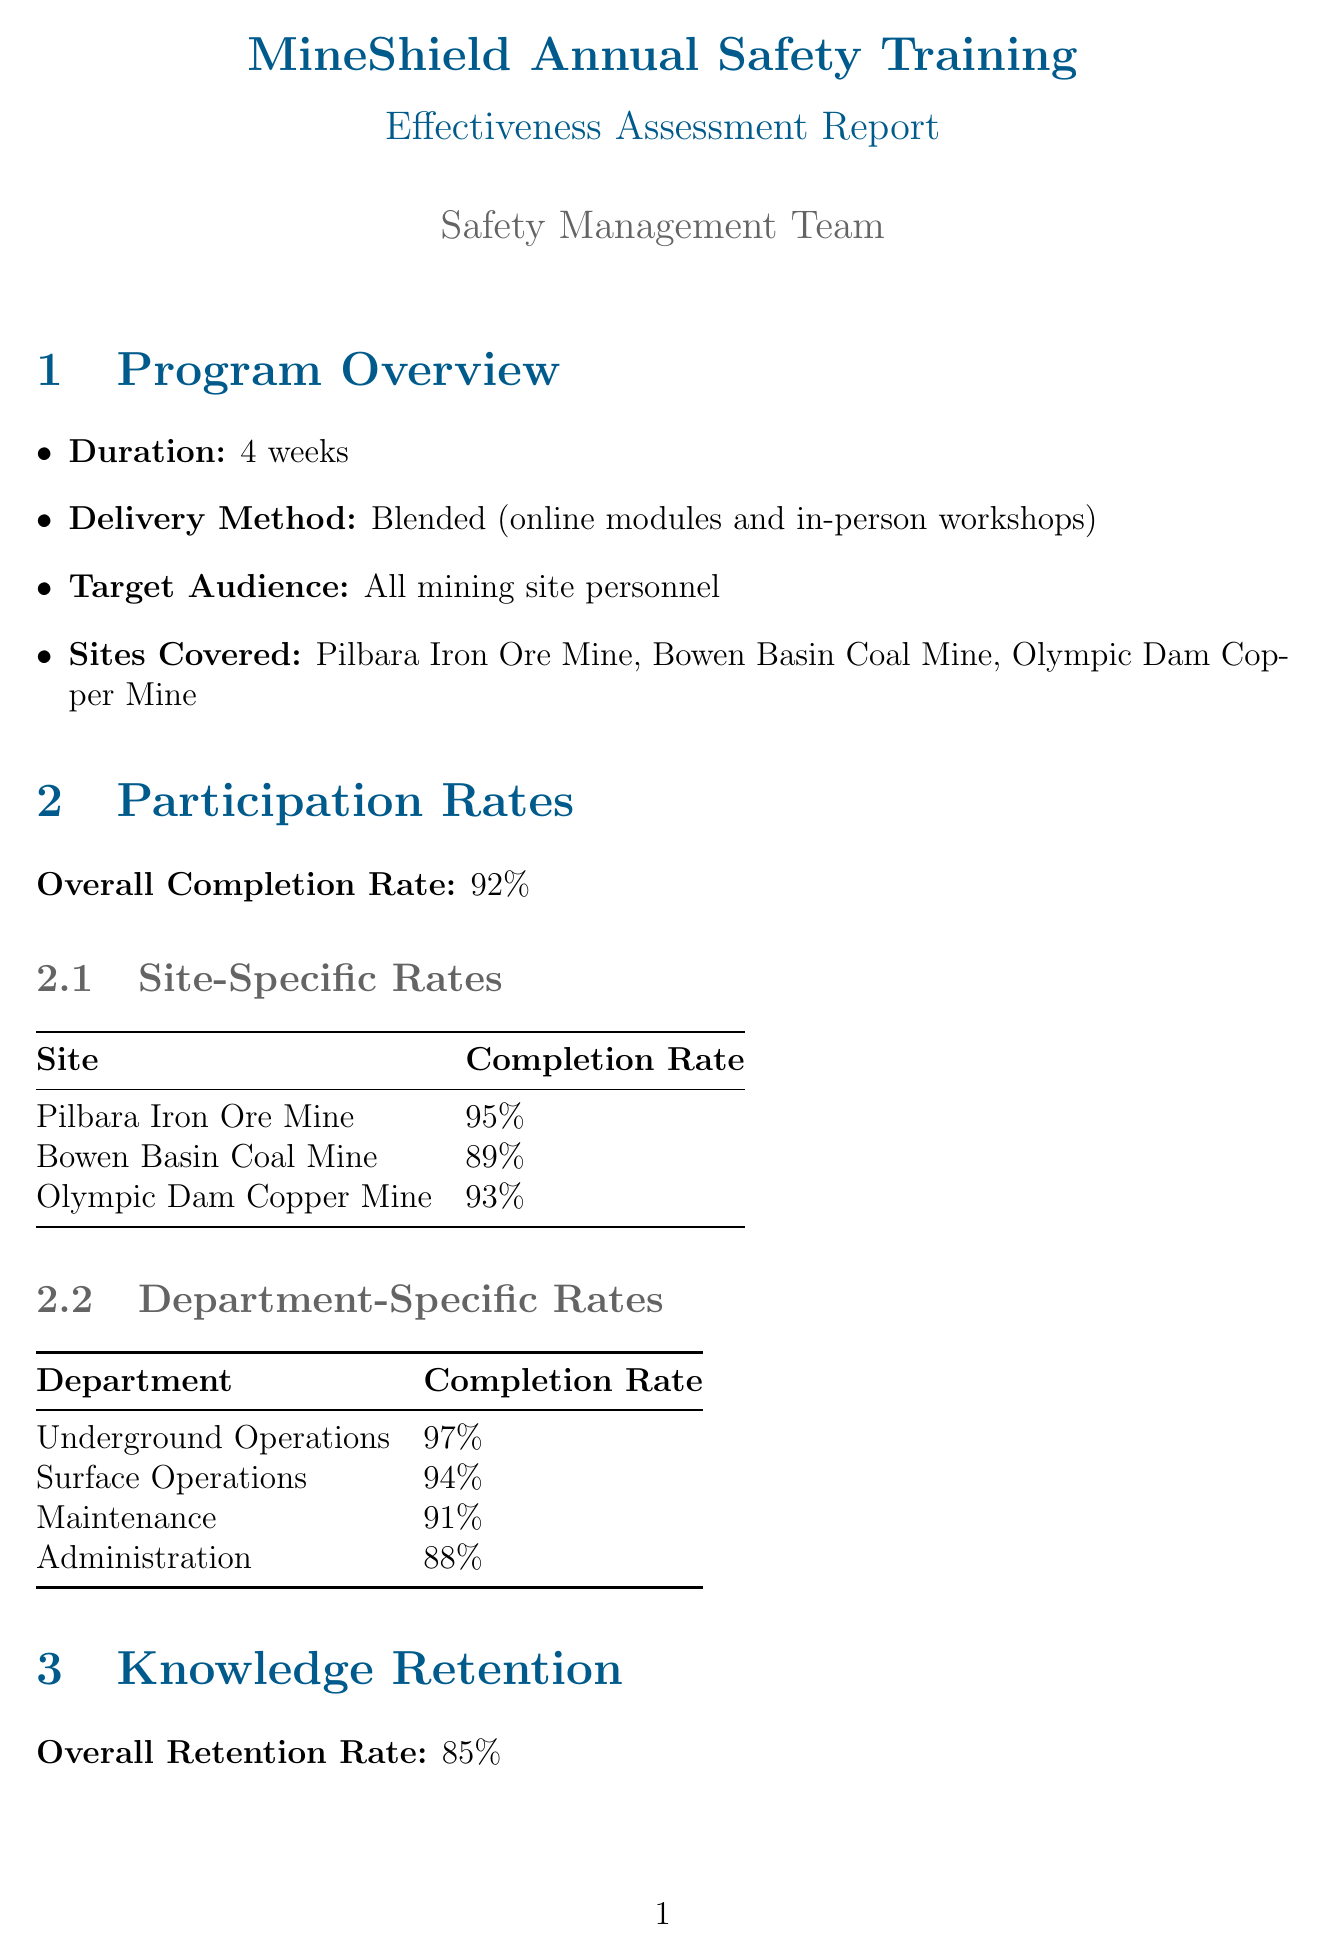What is the overall completion rate? The overall completion rate is provided in the participation rates section of the document.
Answer: 92% What is the participation rate for the Bowen Basin Coal Mine? This information is listed under site-specific rates, detailing the completion rates for each mining site.
Answer: 89% Which module had the lowest retention rate? The module-specific retention rates indicate which areas had lower knowledge retention among participants.
Answer: Environmental Compliance What recommendation is made for the Environmental Compliance module? Each area for improvement includes specific recommendations for enhancing training effectiveness, which can be found in the respective section.
Answer: Develop more interactive and site-specific content for environmental compliance training What percentage of participants accessed content via the mobile app? Technology integration metrics provide insights into participant engagement with the training program's digital resources.
Answer: 68% What was the incident rate reduction achieved through the training program? The training effectiveness metrics provide a summary of the program's impact on incident rates.
Answer: 18% year-over-year decrease What is the estimated ROI of the program? Cost analysis includes a calculation of the program's return on investment based on incident reductions and productivity improvements.
Answer: 280% Which module did participants find most valuable? Participant feedback includes insights into which modules resonated most with attendees during the training.
Answer: Emergency Response 